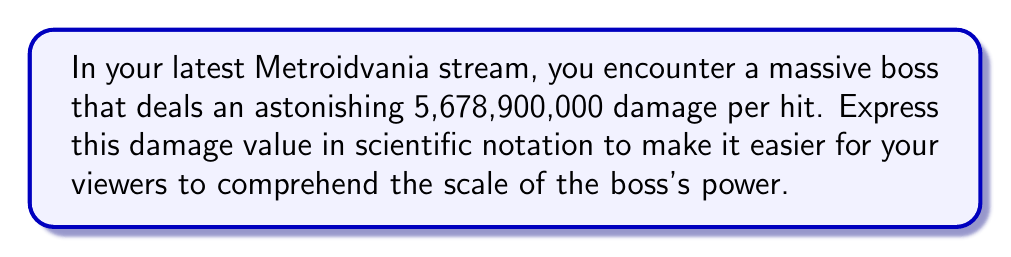Give your solution to this math problem. To convert 5,678,900,000 to scientific notation, we follow these steps:

1. Identify the first non-zero digit: 5
2. Move the decimal point to the right of this digit: 5.6789
3. Count the number of places the decimal point was moved: 9

The number in scientific notation will be of the form:

$$ a \times 10^n $$

Where $a$ is a number between 1 and 10, and $n$ is the number of places the decimal point was moved.

In this case:
$a = 5.6789$
$n = 9$

Therefore, the damage value in scientific notation is:

$$ 5.6789 \times 10^9 $$

This representation makes it easier for your viewers to quickly grasp the magnitude of the boss's damage, as it clearly shows it's in the billions range.
Answer: $5.6789 \times 10^9$ 